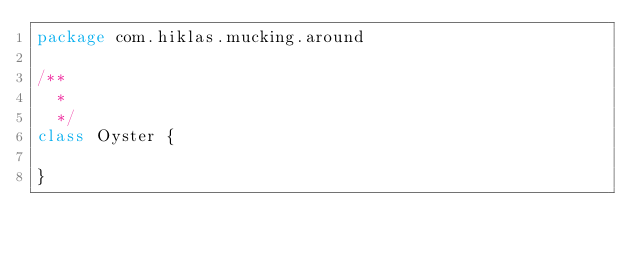Convert code to text. <code><loc_0><loc_0><loc_500><loc_500><_Scala_>package com.hiklas.mucking.around

/**
  *
  */
class Oyster {

}
</code> 